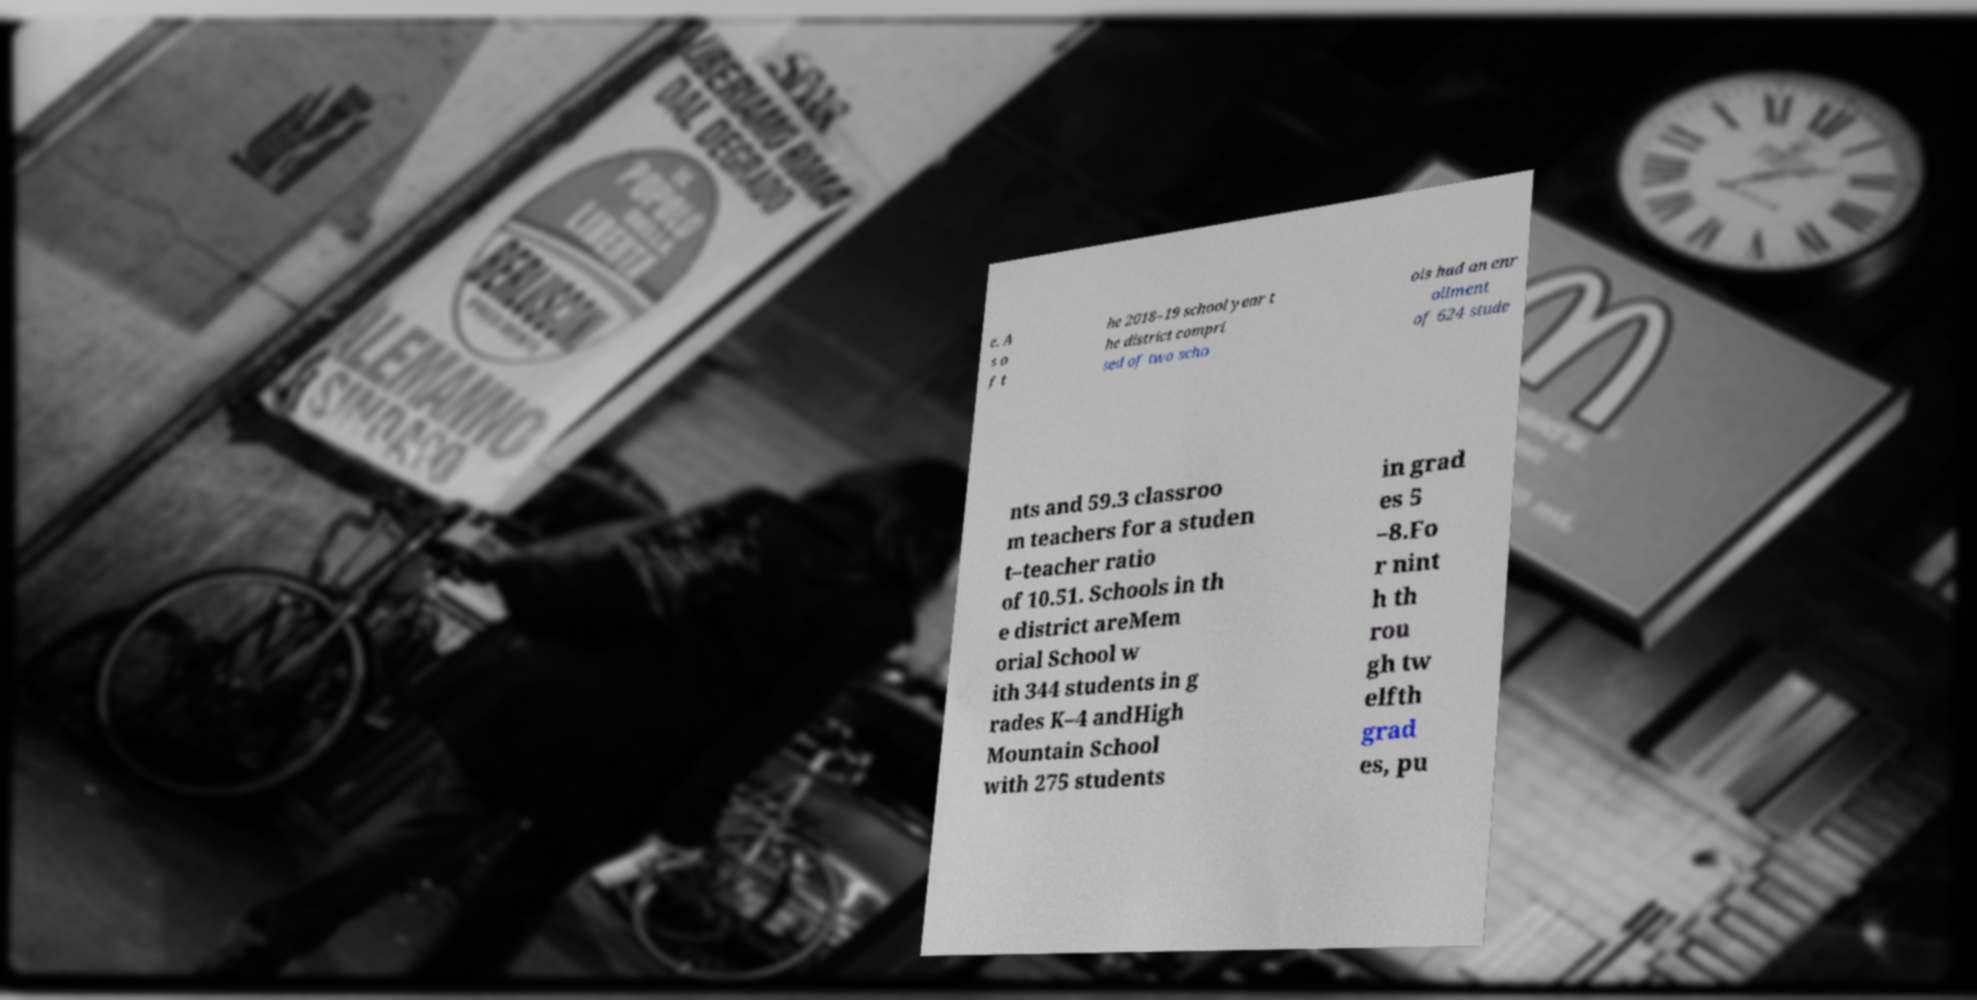Please identify and transcribe the text found in this image. e. A s o f t he 2018–19 school year t he district compri sed of two scho ols had an enr ollment of 624 stude nts and 59.3 classroo m teachers for a studen t–teacher ratio of 10.51. Schools in th e district areMem orial School w ith 344 students in g rades K–4 andHigh Mountain School with 275 students in grad es 5 –8.Fo r nint h th rou gh tw elfth grad es, pu 